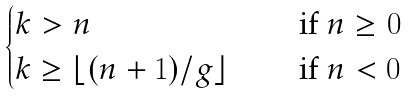Convert formula to latex. <formula><loc_0><loc_0><loc_500><loc_500>\begin{cases} k > n & \quad \text { if } n \geq 0 \\ k \geq \lfloor ( n + 1 ) / g \rfloor & \quad \text { if } n < 0 \end{cases}</formula> 